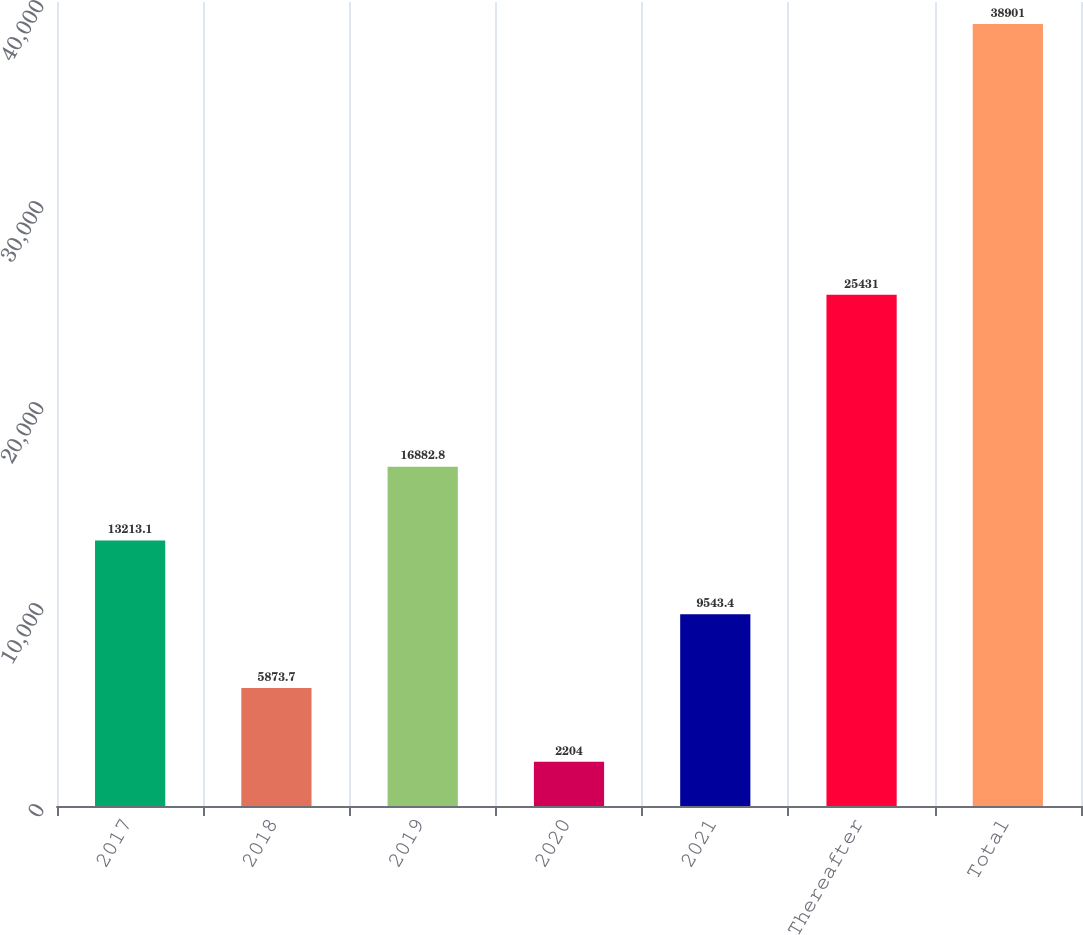Convert chart. <chart><loc_0><loc_0><loc_500><loc_500><bar_chart><fcel>2017<fcel>2018<fcel>2019<fcel>2020<fcel>2021<fcel>Thereafter<fcel>Total<nl><fcel>13213.1<fcel>5873.7<fcel>16882.8<fcel>2204<fcel>9543.4<fcel>25431<fcel>38901<nl></chart> 